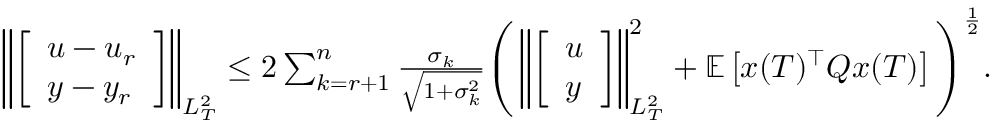Convert formula to latex. <formula><loc_0><loc_0><loc_500><loc_500>\begin{array} { r } { \left \| \left [ \begin{array} { l } { u - u _ { r } } \\ { y - y _ { r } } \end{array} \right ] \right \| _ { L _ { T } ^ { 2 } } \leq 2 \sum _ { k = r + 1 } ^ { n } \frac { \sigma _ { k } } { \sqrt { 1 + \sigma _ { k } ^ { 2 } } } \left ( \left \| \left [ \begin{array} { l } { u } \\ { y } \end{array} \right ] \right \| _ { L _ { T } ^ { 2 } } ^ { 2 } + \mathbb { E } \left [ x ( T ) ^ { \top } Q x ( T ) \right ] \right ) ^ { \frac { 1 } { 2 } } . } \end{array}</formula> 